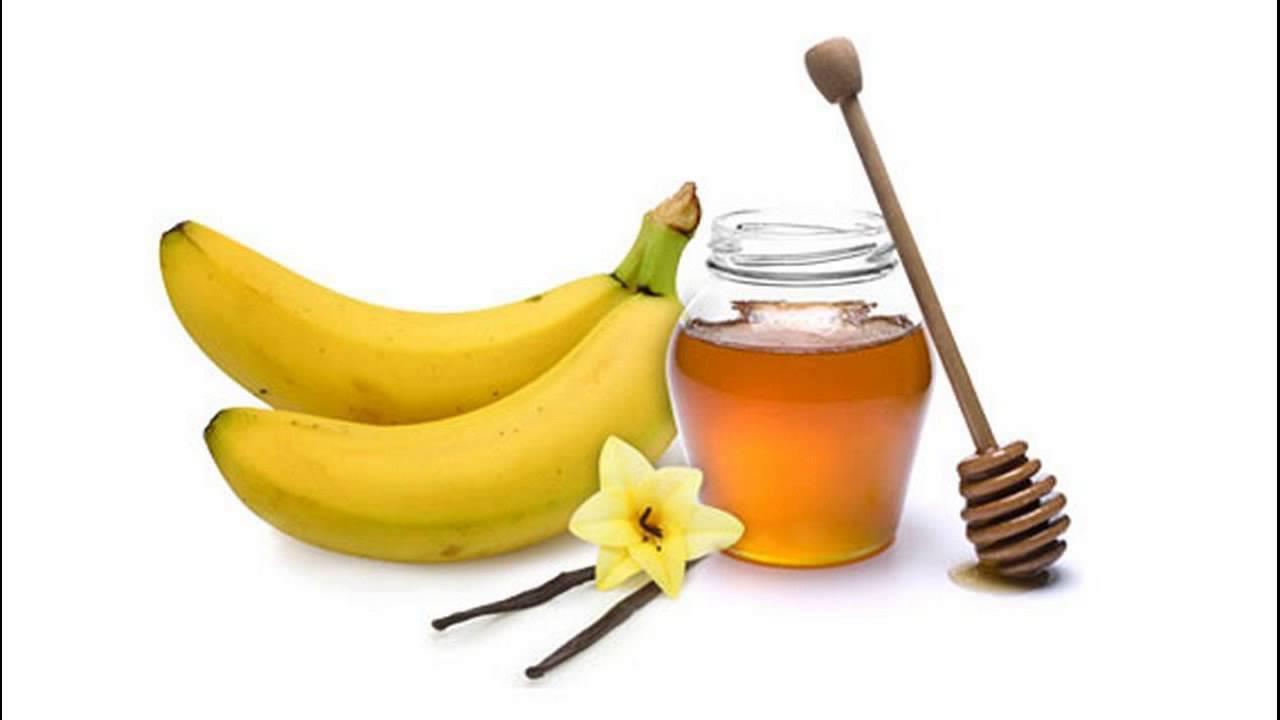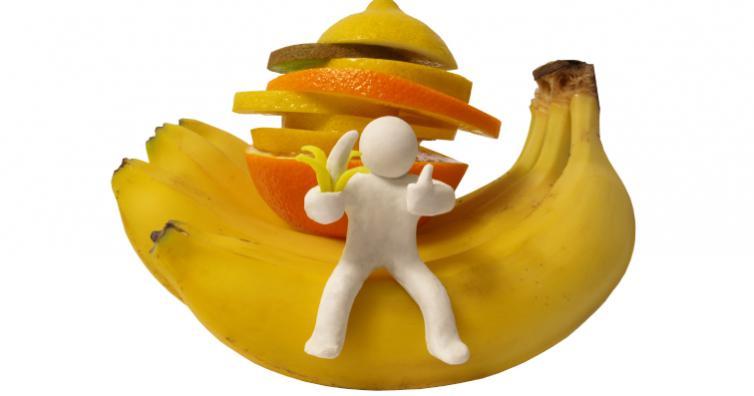The first image is the image on the left, the second image is the image on the right. Considering the images on both sides, is "Atleast one photo in the pair is a single half peeled banana" valid? Answer yes or no. No. 